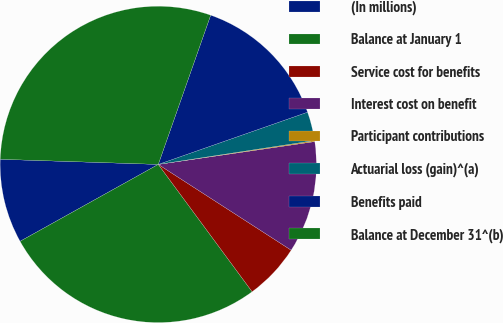Convert chart. <chart><loc_0><loc_0><loc_500><loc_500><pie_chart><fcel>(In millions)<fcel>Balance at January 1<fcel>Service cost for benefits<fcel>Interest cost on benefit<fcel>Participant contributions<fcel>Actuarial loss (gain)^(a)<fcel>Benefits paid<fcel>Balance at December 31^(b)<nl><fcel>8.6%<fcel>27.03%<fcel>5.77%<fcel>11.43%<fcel>0.11%<fcel>2.94%<fcel>14.27%<fcel>29.86%<nl></chart> 